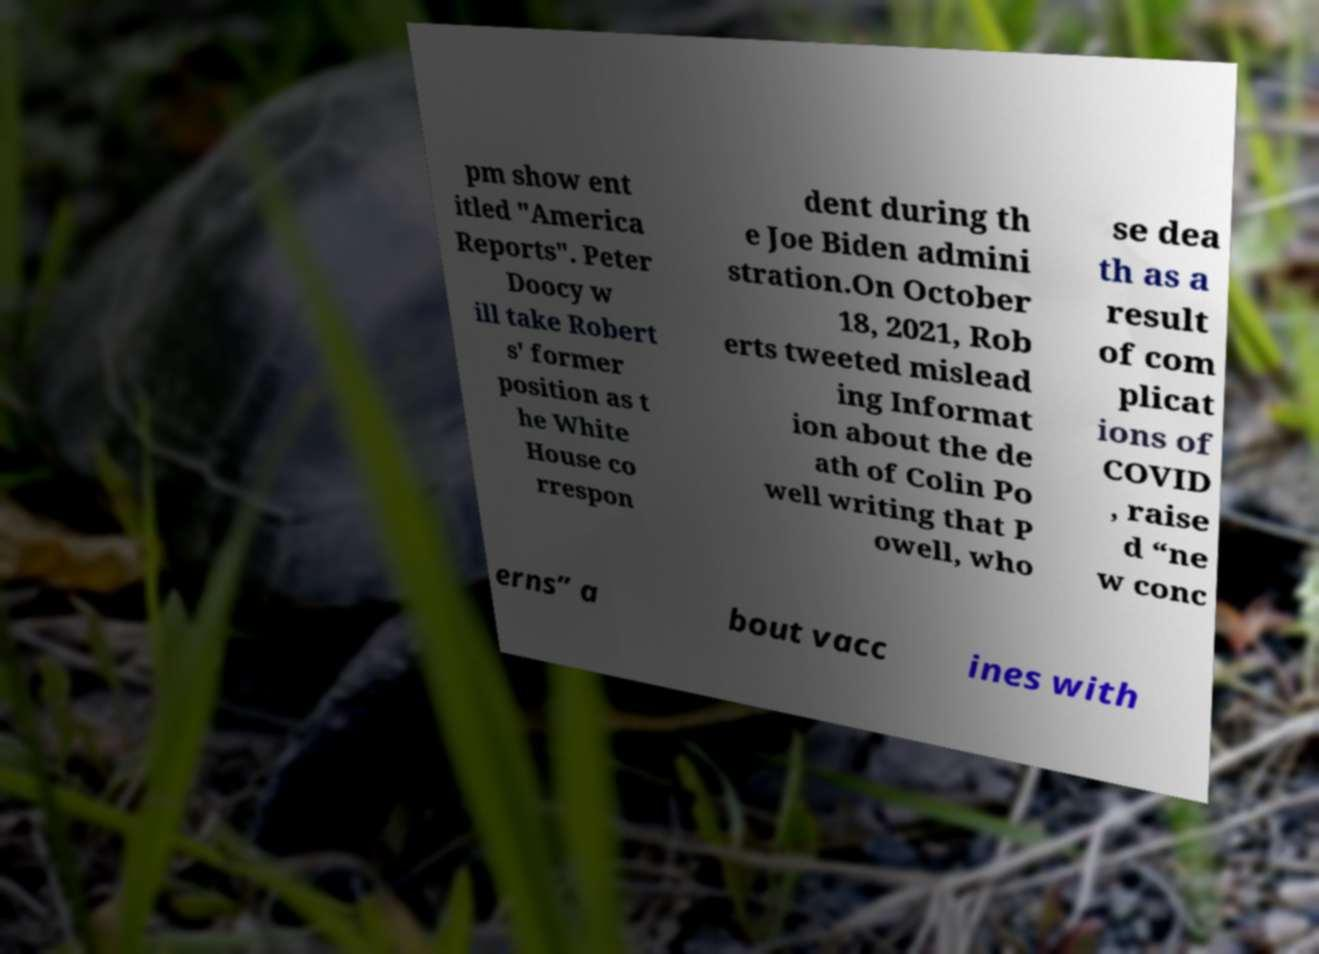Could you extract and type out the text from this image? pm show ent itled "America Reports". Peter Doocy w ill take Robert s' former position as t he White House co rrespon dent during th e Joe Biden admini stration.On October 18, 2021, Rob erts tweeted mislead ing Informat ion about the de ath of Colin Po well writing that P owell, who se dea th as a result of com plicat ions of COVID , raise d “ne w conc erns” a bout vacc ines with 